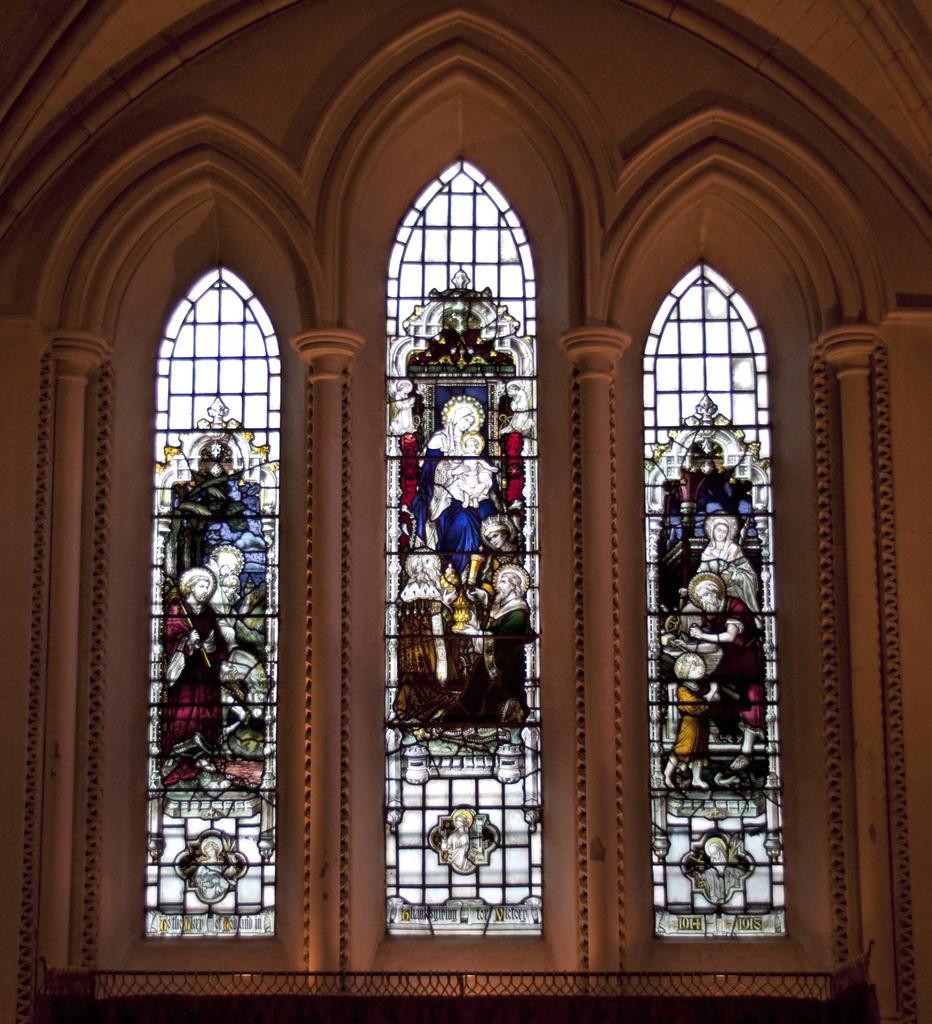Can you describe this image briefly? In this picture we can see the interior of a place with large windows made of glass with different images on it. There are many pillars. 